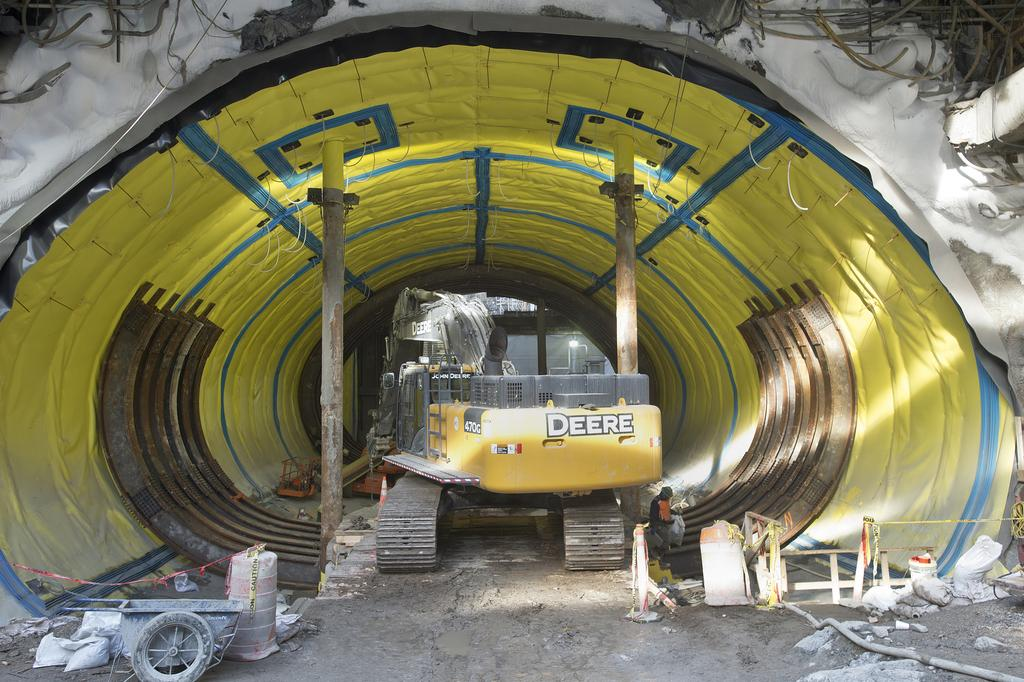What type of location is depicted in the image? There is a construction site in the image. What structures can be seen at the construction site? There are pillars at the construction site. What machinery is present at the construction site? There is an excavator at the construction site. Are there any people present at the construction site? Yes, there is a person at the construction site. What else can be found on the ground at the construction site? There are other items on the ground at the construction site. How many pets are sitting on the chairs in the image? There are no pets or chairs present in the image; it depicts a construction site. 